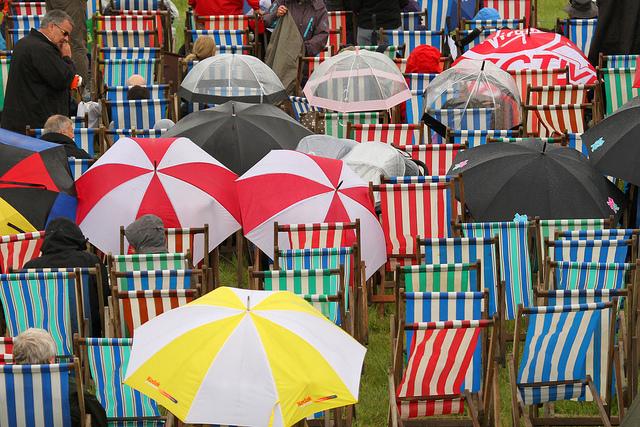What pattern is repeated?
Give a very brief answer. Stripes. What is the man on the left wearing on his face?
Be succinct. Sunglasses. How many umbrellas are shown?
Concise answer only. 12. 